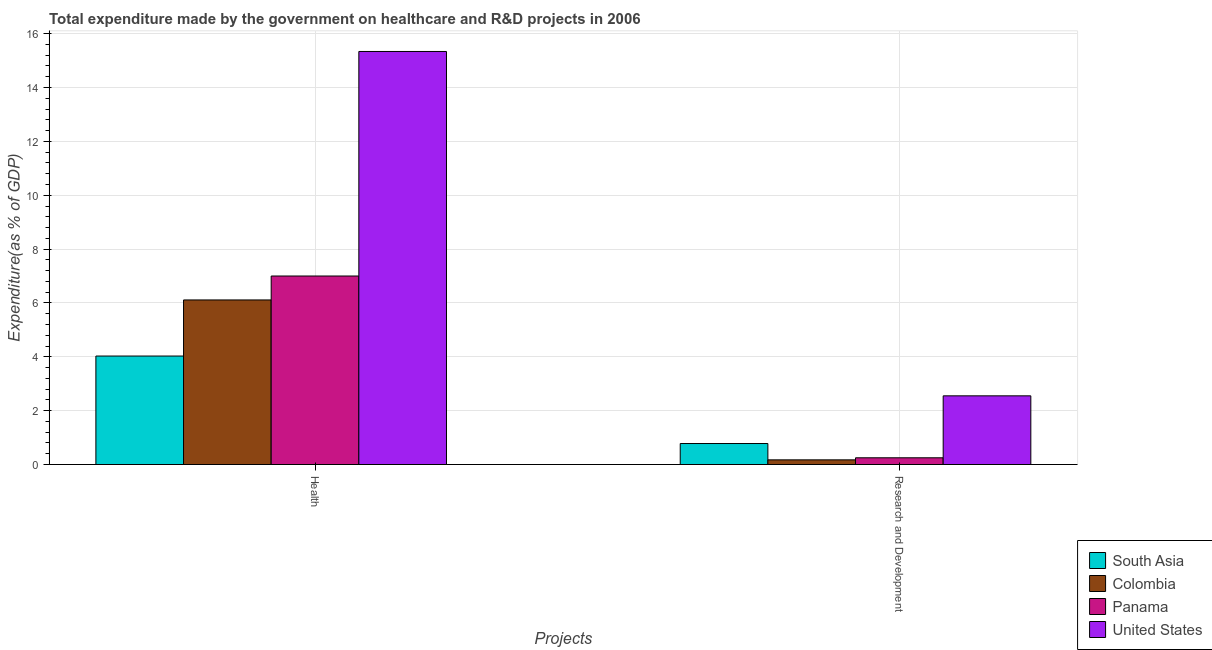Are the number of bars per tick equal to the number of legend labels?
Provide a succinct answer. Yes. How many bars are there on the 2nd tick from the right?
Your answer should be very brief. 4. What is the label of the 1st group of bars from the left?
Ensure brevity in your answer.  Health. What is the expenditure in healthcare in Colombia?
Your answer should be very brief. 6.11. Across all countries, what is the maximum expenditure in healthcare?
Ensure brevity in your answer.  15.34. Across all countries, what is the minimum expenditure in healthcare?
Keep it short and to the point. 4.03. In which country was the expenditure in healthcare maximum?
Your answer should be very brief. United States. In which country was the expenditure in r&d minimum?
Offer a terse response. Colombia. What is the total expenditure in r&d in the graph?
Ensure brevity in your answer.  3.75. What is the difference between the expenditure in r&d in South Asia and that in Panama?
Your answer should be very brief. 0.53. What is the difference between the expenditure in r&d in Panama and the expenditure in healthcare in Colombia?
Provide a short and direct response. -5.86. What is the average expenditure in r&d per country?
Offer a terse response. 0.94. What is the difference between the expenditure in healthcare and expenditure in r&d in South Asia?
Ensure brevity in your answer.  3.25. In how many countries, is the expenditure in healthcare greater than 5.6 %?
Provide a succinct answer. 3. What is the ratio of the expenditure in healthcare in Panama to that in Colombia?
Provide a short and direct response. 1.15. Is the expenditure in healthcare in United States less than that in Colombia?
Your answer should be compact. No. What does the 2nd bar from the left in Research and Development represents?
Ensure brevity in your answer.  Colombia. What does the 2nd bar from the right in Health represents?
Offer a terse response. Panama. How many bars are there?
Your answer should be very brief. 8. Are all the bars in the graph horizontal?
Your answer should be compact. No. What is the difference between two consecutive major ticks on the Y-axis?
Keep it short and to the point. 2. Are the values on the major ticks of Y-axis written in scientific E-notation?
Provide a short and direct response. No. What is the title of the graph?
Offer a terse response. Total expenditure made by the government on healthcare and R&D projects in 2006. Does "Mexico" appear as one of the legend labels in the graph?
Offer a very short reply. No. What is the label or title of the X-axis?
Your answer should be compact. Projects. What is the label or title of the Y-axis?
Provide a succinct answer. Expenditure(as % of GDP). What is the Expenditure(as % of GDP) in South Asia in Health?
Keep it short and to the point. 4.03. What is the Expenditure(as % of GDP) of Colombia in Health?
Offer a terse response. 6.11. What is the Expenditure(as % of GDP) of Panama in Health?
Offer a very short reply. 7. What is the Expenditure(as % of GDP) of United States in Health?
Ensure brevity in your answer.  15.34. What is the Expenditure(as % of GDP) of South Asia in Research and Development?
Your answer should be very brief. 0.78. What is the Expenditure(as % of GDP) in Colombia in Research and Development?
Keep it short and to the point. 0.17. What is the Expenditure(as % of GDP) of Panama in Research and Development?
Ensure brevity in your answer.  0.25. What is the Expenditure(as % of GDP) of United States in Research and Development?
Give a very brief answer. 2.55. Across all Projects, what is the maximum Expenditure(as % of GDP) in South Asia?
Your response must be concise. 4.03. Across all Projects, what is the maximum Expenditure(as % of GDP) of Colombia?
Provide a short and direct response. 6.11. Across all Projects, what is the maximum Expenditure(as % of GDP) of Panama?
Your answer should be compact. 7. Across all Projects, what is the maximum Expenditure(as % of GDP) of United States?
Your response must be concise. 15.34. Across all Projects, what is the minimum Expenditure(as % of GDP) of South Asia?
Make the answer very short. 0.78. Across all Projects, what is the minimum Expenditure(as % of GDP) of Colombia?
Your response must be concise. 0.17. Across all Projects, what is the minimum Expenditure(as % of GDP) in Panama?
Your response must be concise. 0.25. Across all Projects, what is the minimum Expenditure(as % of GDP) in United States?
Provide a short and direct response. 2.55. What is the total Expenditure(as % of GDP) of South Asia in the graph?
Offer a very short reply. 4.81. What is the total Expenditure(as % of GDP) in Colombia in the graph?
Keep it short and to the point. 6.28. What is the total Expenditure(as % of GDP) of Panama in the graph?
Provide a succinct answer. 7.25. What is the total Expenditure(as % of GDP) of United States in the graph?
Keep it short and to the point. 17.89. What is the difference between the Expenditure(as % of GDP) in South Asia in Health and that in Research and Development?
Keep it short and to the point. 3.25. What is the difference between the Expenditure(as % of GDP) in Colombia in Health and that in Research and Development?
Your answer should be very brief. 5.94. What is the difference between the Expenditure(as % of GDP) of Panama in Health and that in Research and Development?
Offer a terse response. 6.75. What is the difference between the Expenditure(as % of GDP) of United States in Health and that in Research and Development?
Offer a very short reply. 12.79. What is the difference between the Expenditure(as % of GDP) of South Asia in Health and the Expenditure(as % of GDP) of Colombia in Research and Development?
Your response must be concise. 3.86. What is the difference between the Expenditure(as % of GDP) of South Asia in Health and the Expenditure(as % of GDP) of Panama in Research and Development?
Make the answer very short. 3.78. What is the difference between the Expenditure(as % of GDP) in South Asia in Health and the Expenditure(as % of GDP) in United States in Research and Development?
Your answer should be compact. 1.48. What is the difference between the Expenditure(as % of GDP) of Colombia in Health and the Expenditure(as % of GDP) of Panama in Research and Development?
Give a very brief answer. 5.86. What is the difference between the Expenditure(as % of GDP) of Colombia in Health and the Expenditure(as % of GDP) of United States in Research and Development?
Make the answer very short. 3.56. What is the difference between the Expenditure(as % of GDP) of Panama in Health and the Expenditure(as % of GDP) of United States in Research and Development?
Offer a very short reply. 4.45. What is the average Expenditure(as % of GDP) of South Asia per Projects?
Your answer should be very brief. 2.4. What is the average Expenditure(as % of GDP) of Colombia per Projects?
Your answer should be compact. 3.14. What is the average Expenditure(as % of GDP) of Panama per Projects?
Offer a terse response. 3.62. What is the average Expenditure(as % of GDP) of United States per Projects?
Provide a short and direct response. 8.94. What is the difference between the Expenditure(as % of GDP) of South Asia and Expenditure(as % of GDP) of Colombia in Health?
Give a very brief answer. -2.08. What is the difference between the Expenditure(as % of GDP) in South Asia and Expenditure(as % of GDP) in Panama in Health?
Provide a short and direct response. -2.97. What is the difference between the Expenditure(as % of GDP) of South Asia and Expenditure(as % of GDP) of United States in Health?
Make the answer very short. -11.31. What is the difference between the Expenditure(as % of GDP) of Colombia and Expenditure(as % of GDP) of Panama in Health?
Offer a very short reply. -0.89. What is the difference between the Expenditure(as % of GDP) in Colombia and Expenditure(as % of GDP) in United States in Health?
Make the answer very short. -9.23. What is the difference between the Expenditure(as % of GDP) of Panama and Expenditure(as % of GDP) of United States in Health?
Provide a succinct answer. -8.34. What is the difference between the Expenditure(as % of GDP) in South Asia and Expenditure(as % of GDP) in Colombia in Research and Development?
Give a very brief answer. 0.61. What is the difference between the Expenditure(as % of GDP) in South Asia and Expenditure(as % of GDP) in Panama in Research and Development?
Your answer should be very brief. 0.53. What is the difference between the Expenditure(as % of GDP) of South Asia and Expenditure(as % of GDP) of United States in Research and Development?
Provide a succinct answer. -1.77. What is the difference between the Expenditure(as % of GDP) of Colombia and Expenditure(as % of GDP) of Panama in Research and Development?
Keep it short and to the point. -0.08. What is the difference between the Expenditure(as % of GDP) in Colombia and Expenditure(as % of GDP) in United States in Research and Development?
Your answer should be very brief. -2.38. What is the difference between the Expenditure(as % of GDP) in Panama and Expenditure(as % of GDP) in United States in Research and Development?
Ensure brevity in your answer.  -2.3. What is the ratio of the Expenditure(as % of GDP) of South Asia in Health to that in Research and Development?
Offer a terse response. 5.17. What is the ratio of the Expenditure(as % of GDP) in Colombia in Health to that in Research and Development?
Keep it short and to the point. 35.4. What is the ratio of the Expenditure(as % of GDP) of Panama in Health to that in Research and Development?
Give a very brief answer. 28.1. What is the ratio of the Expenditure(as % of GDP) of United States in Health to that in Research and Development?
Offer a terse response. 6.02. What is the difference between the highest and the second highest Expenditure(as % of GDP) in South Asia?
Ensure brevity in your answer.  3.25. What is the difference between the highest and the second highest Expenditure(as % of GDP) of Colombia?
Your response must be concise. 5.94. What is the difference between the highest and the second highest Expenditure(as % of GDP) of Panama?
Keep it short and to the point. 6.75. What is the difference between the highest and the second highest Expenditure(as % of GDP) of United States?
Provide a succinct answer. 12.79. What is the difference between the highest and the lowest Expenditure(as % of GDP) in South Asia?
Your response must be concise. 3.25. What is the difference between the highest and the lowest Expenditure(as % of GDP) in Colombia?
Provide a short and direct response. 5.94. What is the difference between the highest and the lowest Expenditure(as % of GDP) in Panama?
Give a very brief answer. 6.75. What is the difference between the highest and the lowest Expenditure(as % of GDP) in United States?
Keep it short and to the point. 12.79. 